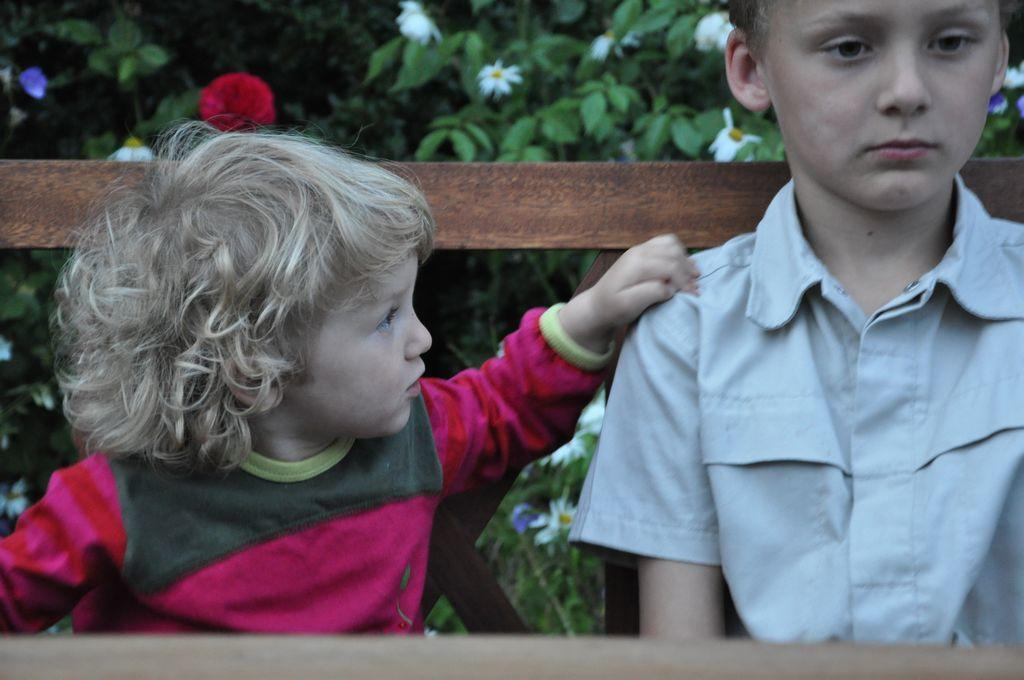Who are the people in the image? There is a small girl and a boy in the image. What are the children doing in the image? Both the girl and the boy are sitting on a bench. What can be seen in the background of the image? There are plants with flowers visible in the background of the image. What type of bag is the crow carrying in the image? There is no crow or bag present in the image. 